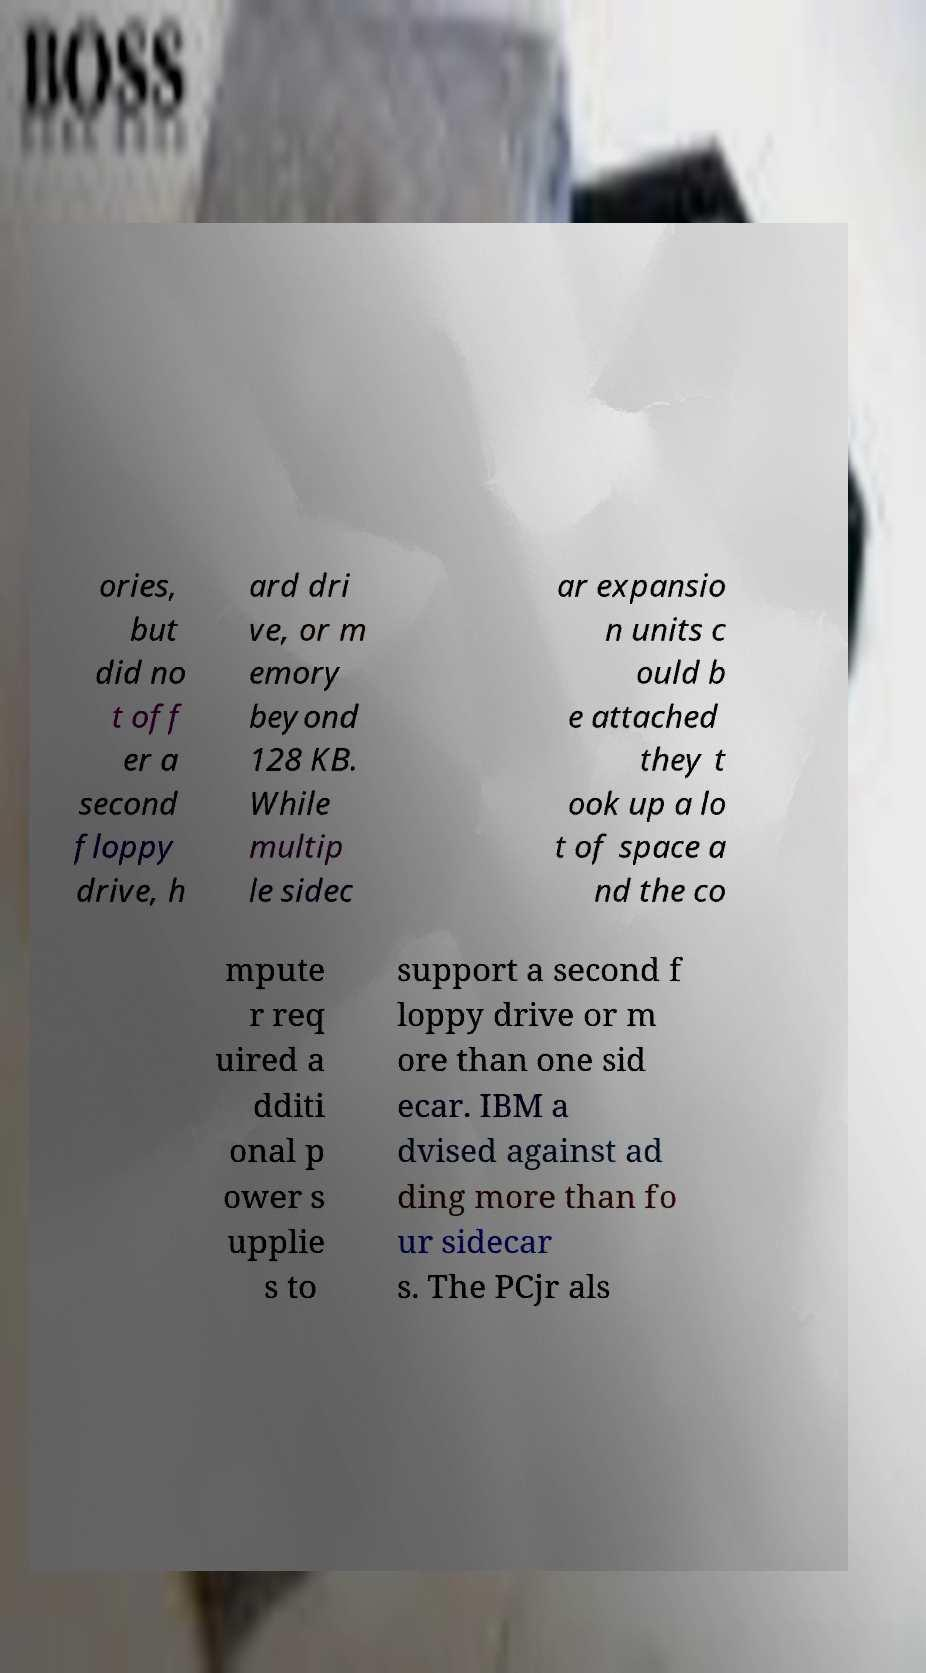There's text embedded in this image that I need extracted. Can you transcribe it verbatim? ories, but did no t off er a second floppy drive, h ard dri ve, or m emory beyond 128 KB. While multip le sidec ar expansio n units c ould b e attached they t ook up a lo t of space a nd the co mpute r req uired a dditi onal p ower s upplie s to support a second f loppy drive or m ore than one sid ecar. IBM a dvised against ad ding more than fo ur sidecar s. The PCjr als 